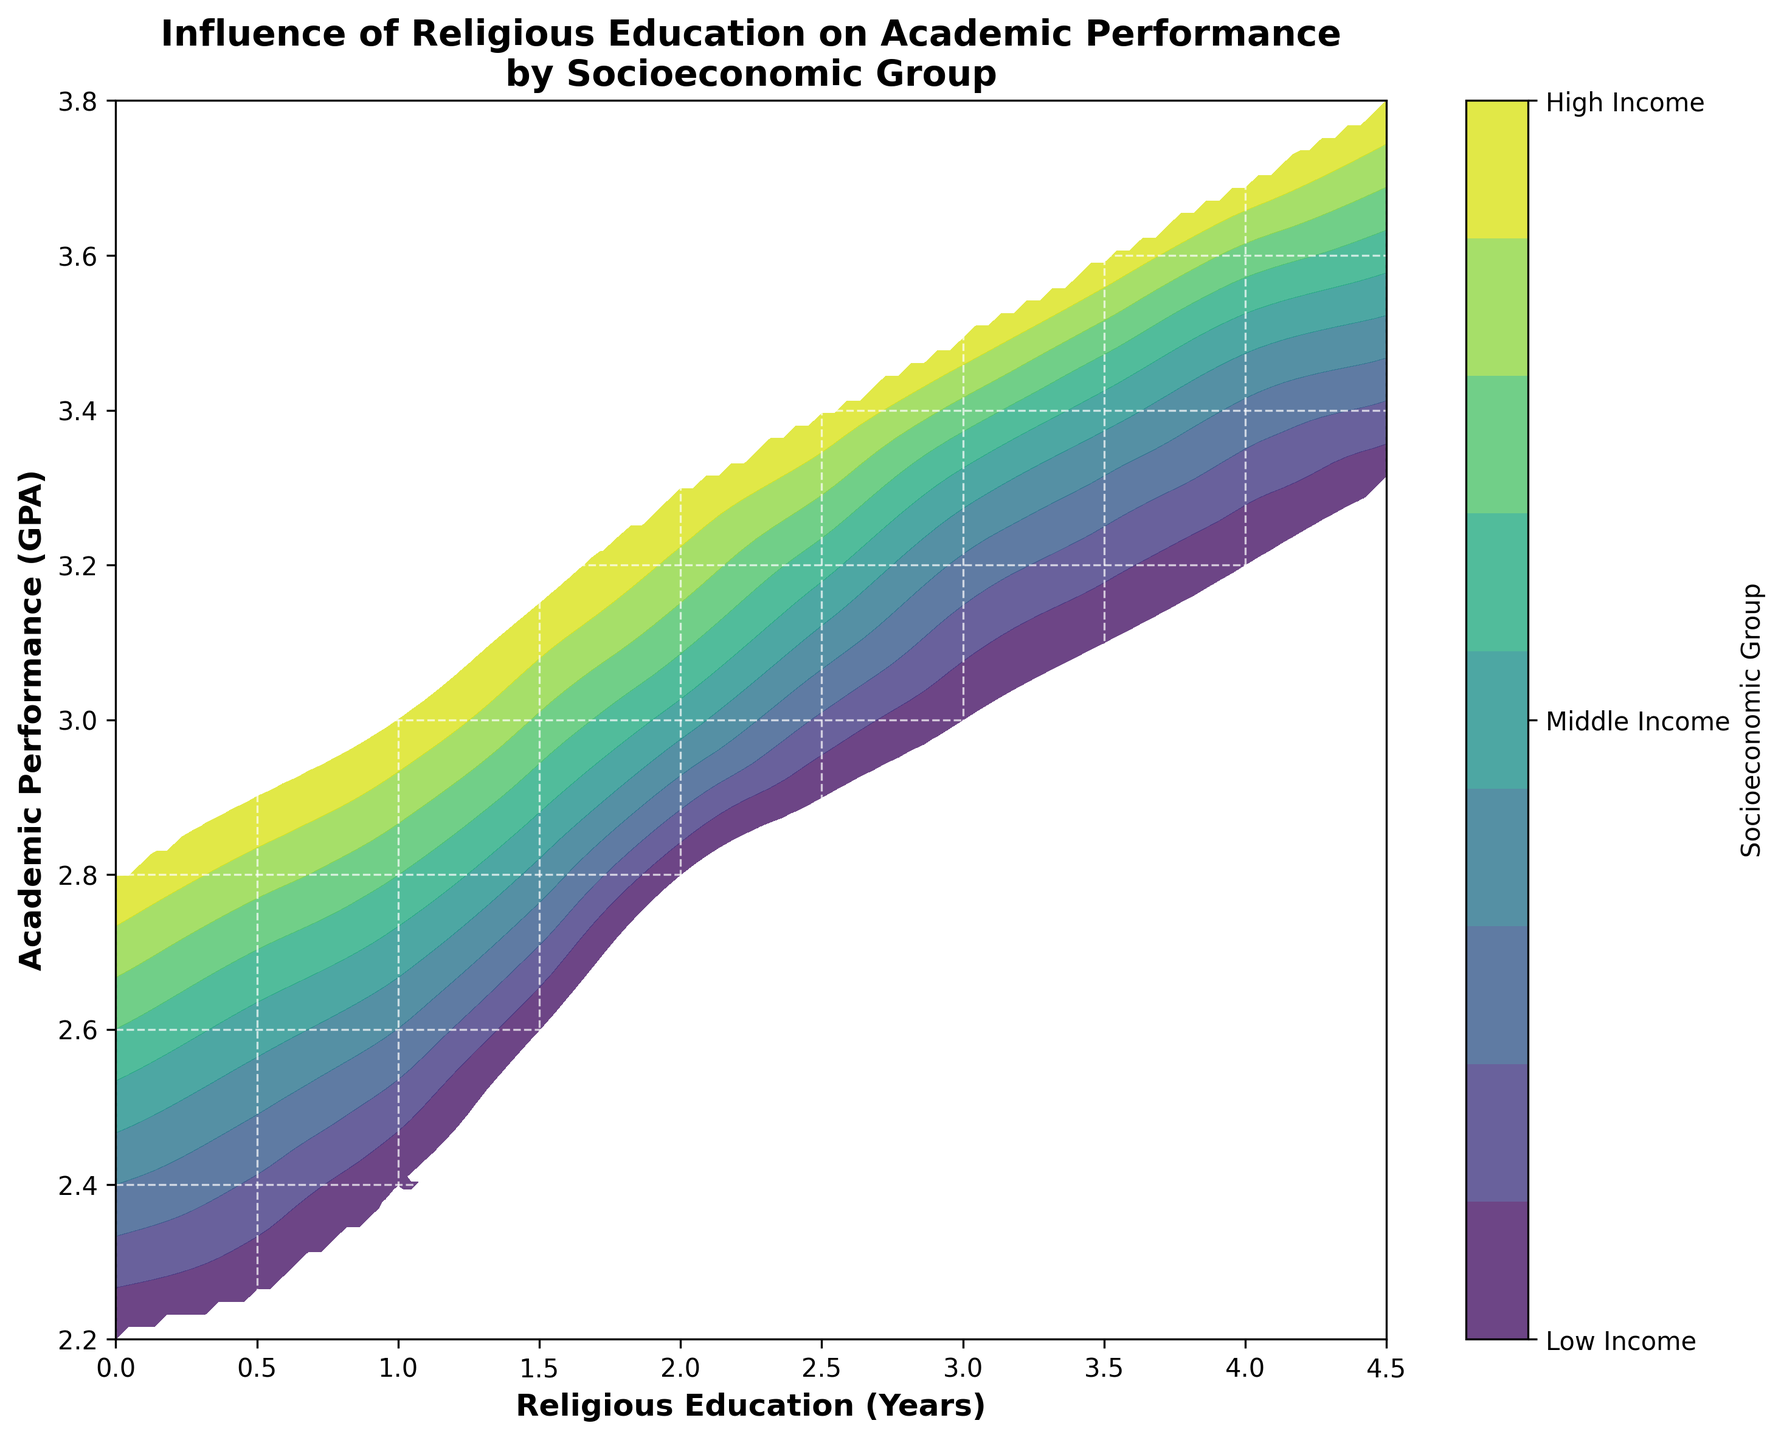what is the title of the plot? The title is written at the top of the plot and states the main focus of the visual representation. By looking at the top, you can see the title "Influence of Religious Education on Academic Performance by Socioeconomic Group".
Answer: Influence of Religious Education on Academic Performance by Socioeconomic Group what are the labels on the x and y axes? The labels are found next to the axes and describe what each axis represents. The x-axis label is 'Religious Education (Years)' and the y-axis label is 'Academic Performance (GPA)'.
Answer: Religious Education (Years) and Academic Performance (GPA) which socioeconomic group is represented by the lowest and highest values of the colorbar? The colorbar on the right of the plot shows that 'Low Income' is at the lowest value and 'High Income' is at the highest value. This is indicated by the ticks marked by the group names corresponding to the numerical color levels.
Answer: Low Income and High Income how does academic performance change with increasing religious education for the High Income group? By examining the contour plot, it is observed that as the number of years of religious education increases from 0 to 4.5 years, the academic performance (GPA) for the High Income group progressively improves from 2.8 to 3.8.
Answer: It improves progressively is there a socioeconomic group that shows a distinct improvement in academic performance with increase in religious education? Checking the contour lines, all three groups show improvement, but the Middle Income and High Income groups exhibit a more pronounced improvement compared to the Low Income group when religious education incrementally increases.
Answer: Middle Income and High Income what would be the approximate GPA for a Low Income student with 2 years of religious education? Locate the point where 'Religious Education (Years)' equals 2 and follow the contour line horizontally to intersect the Low Income region. The approximate GPA at this point is around 2.8.
Answer: Around 2.8 compare the GPA of Middle Income group with 1 year and 3 years of religious education. To compare, locate where 'Religious Education (Years)' is 1 and 3 on the x-axis and follow vertically along to the Middle Income shading. The GPA moves from about 2.7 to roughly 3.3.
Answer: 2.7 at 1 year, 3.3 at 3 years what is the GDP for a High Income student with 1.5 years of religious education, according to the plot? Find where 'Religious Education (Years)' is 1.5 on the x-axis, trace this to the area determined by the High Income color, and read the corresponding GPA. The GPA is approximately 3.15 for this point.
Answer: Approximately 3.15 at what academic performance level do different socioeconomic groups start diverging significantly according to the plot? Following the contour lines horizontally, significant divergence can be seen around a GPA of 3.0, where separation between Low, Middle, and High Income regions becomes more noticeable.
Answer: Around 3.0 